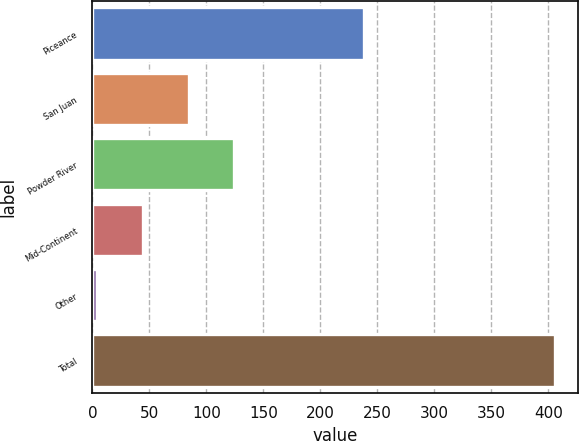Convert chart to OTSL. <chart><loc_0><loc_0><loc_500><loc_500><bar_chart><fcel>Piceance<fcel>San Juan<fcel>Powder River<fcel>Mid-Continent<fcel>Other<fcel>Total<nl><fcel>238<fcel>84.4<fcel>124.6<fcel>44.2<fcel>4<fcel>406<nl></chart> 